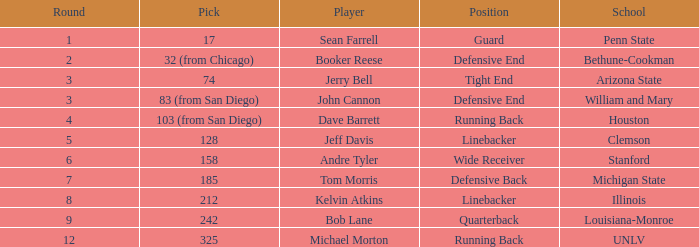In which round is pick number 242? 1.0. 